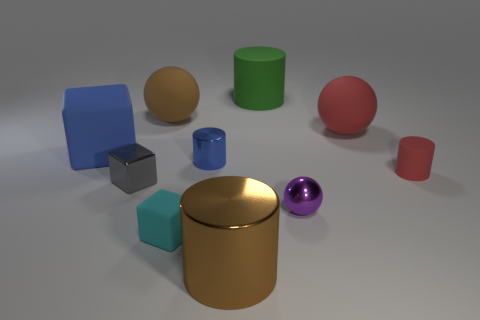Subtract all blue cylinders. How many cylinders are left? 3 Subtract all small red cylinders. How many cylinders are left? 3 Subtract all gray cylinders. Subtract all green blocks. How many cylinders are left? 4 Subtract all balls. How many objects are left? 7 Add 1 brown metallic objects. How many brown metallic objects exist? 2 Subtract 0 yellow cylinders. How many objects are left? 10 Subtract all tiny blue metallic objects. Subtract all yellow shiny blocks. How many objects are left? 9 Add 1 small blue shiny cylinders. How many small blue shiny cylinders are left? 2 